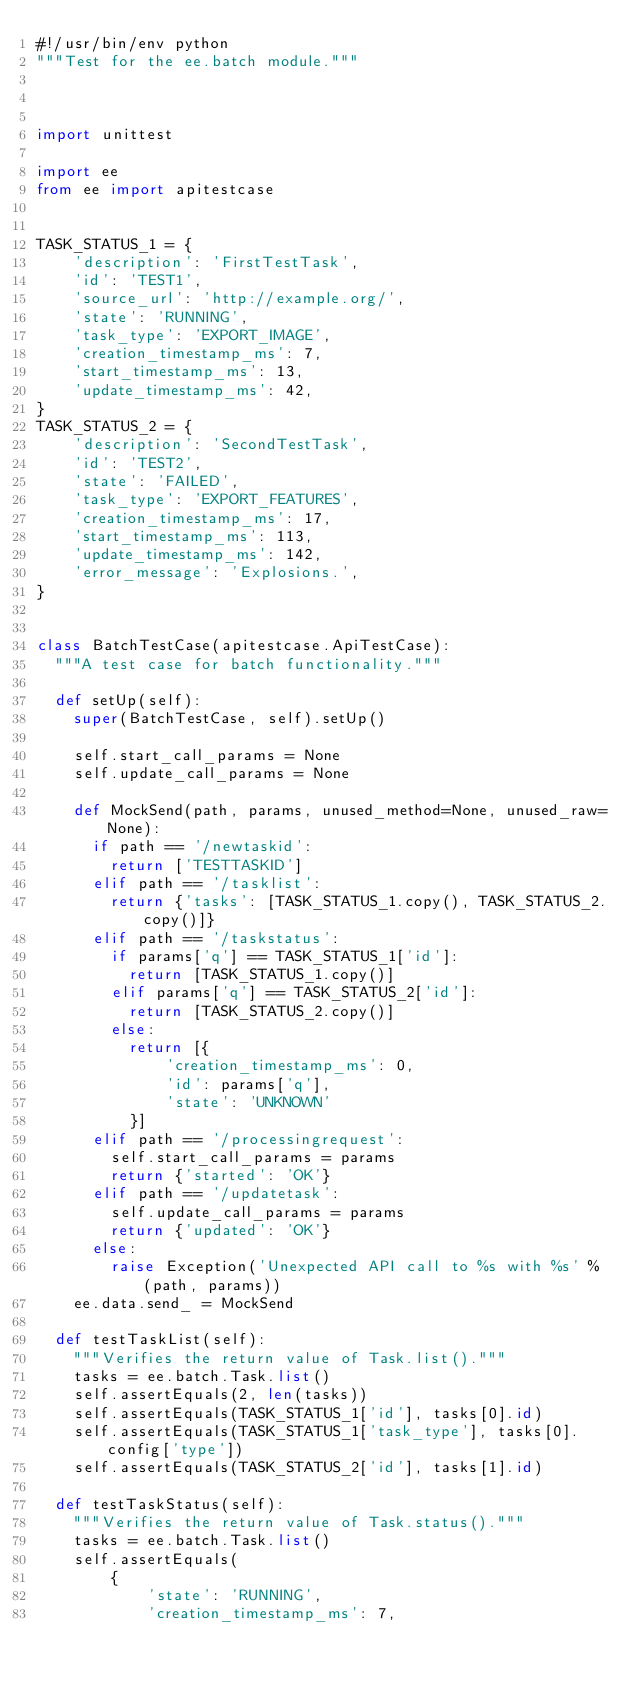Convert code to text. <code><loc_0><loc_0><loc_500><loc_500><_Python_>#!/usr/bin/env python
"""Test for the ee.batch module."""



import unittest

import ee
from ee import apitestcase


TASK_STATUS_1 = {
    'description': 'FirstTestTask',
    'id': 'TEST1',
    'source_url': 'http://example.org/',
    'state': 'RUNNING',
    'task_type': 'EXPORT_IMAGE',
    'creation_timestamp_ms': 7,
    'start_timestamp_ms': 13,
    'update_timestamp_ms': 42,
}
TASK_STATUS_2 = {
    'description': 'SecondTestTask',
    'id': 'TEST2',
    'state': 'FAILED',
    'task_type': 'EXPORT_FEATURES',
    'creation_timestamp_ms': 17,
    'start_timestamp_ms': 113,
    'update_timestamp_ms': 142,
    'error_message': 'Explosions.',
}


class BatchTestCase(apitestcase.ApiTestCase):
  """A test case for batch functionality."""

  def setUp(self):
    super(BatchTestCase, self).setUp()

    self.start_call_params = None
    self.update_call_params = None

    def MockSend(path, params, unused_method=None, unused_raw=None):
      if path == '/newtaskid':
        return ['TESTTASKID']
      elif path == '/tasklist':
        return {'tasks': [TASK_STATUS_1.copy(), TASK_STATUS_2.copy()]}
      elif path == '/taskstatus':
        if params['q'] == TASK_STATUS_1['id']:
          return [TASK_STATUS_1.copy()]
        elif params['q'] == TASK_STATUS_2['id']:
          return [TASK_STATUS_2.copy()]
        else:
          return [{
              'creation_timestamp_ms': 0,
              'id': params['q'],
              'state': 'UNKNOWN'
          }]
      elif path == '/processingrequest':
        self.start_call_params = params
        return {'started': 'OK'}
      elif path == '/updatetask':
        self.update_call_params = params
        return {'updated': 'OK'}
      else:
        raise Exception('Unexpected API call to %s with %s' % (path, params))
    ee.data.send_ = MockSend

  def testTaskList(self):
    """Verifies the return value of Task.list()."""
    tasks = ee.batch.Task.list()
    self.assertEquals(2, len(tasks))
    self.assertEquals(TASK_STATUS_1['id'], tasks[0].id)
    self.assertEquals(TASK_STATUS_1['task_type'], tasks[0].config['type'])
    self.assertEquals(TASK_STATUS_2['id'], tasks[1].id)

  def testTaskStatus(self):
    """Verifies the return value of Task.status()."""
    tasks = ee.batch.Task.list()
    self.assertEquals(
        {
            'state': 'RUNNING',
            'creation_timestamp_ms': 7,</code> 